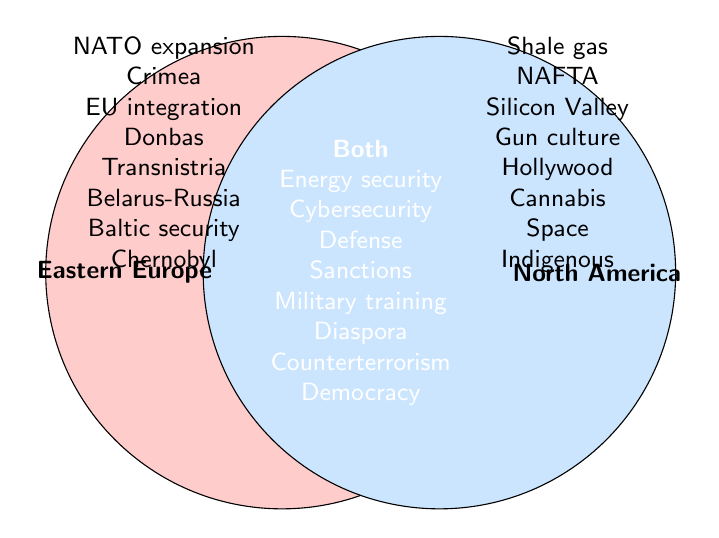What are the geopolitical interests that are exclusive to Eastern Europe? By looking at the left circle labeled "Eastern Europe," we can identify the interests listed in this group that are not shared with North America. These interests are NATO expansion, Crimea annexation, EU integration, Donbas conflict, Transnistria issue, Belarus-Russia relations, Baltic states security, and Chernobyl legacy.
Answer: NATO expansion, Crimea annexation, EU integration, Donbas conflict, Transnistria issue, Belarus-Russia relations, Baltic states security, Chernobyl legacy Which group has the topic of "Cybersecurity"? By examining the overlap section in the Venn Diagram where both circles intersect, "Cybersecurity" is found there, indicating it is a shared interest between Eastern Europe and North America.
Answer: Both How many interests are unique to North America? By counting the topics in the right circle labeled "North America" that do not overlap with the left circle, we find there are eight interests: shale gas revolution, NAFTA, Silicon Valley, gun culture, Hollywood influence, cannabis legalization, space exploration, and indigenous rights.
Answer: 8 Which geopolitical topics are shared between Eastern Europe and North America? By examining the overlapping section of the Venn Diagram, we identify the topics that are common to both regions: energy security, cybersecurity, defense cooperation, economic sanctions, military training, diaspora communities, counterterrorism, and democratic values.
Answer: Energy security, cybersecurity, defense cooperation, economic sanctions, military training, diaspora communities, counterterrorism, democratic values Compare the number of interests specific to Eastern Europe with those specific to North America. Which has more, and by how much? Eastern Europe has 8 unique interests while North America also has 8 unique interests. The count is equal, so neither has more.
Answer: Equal Which side discusses "Energy security" and is it unique or shared? "Energy security" is found in the middle overlapping section of the Venn Diagram, indicating that it is a shared interest between both Eastern Europe and North America.
Answer: Both, shared Identify an interest that deals with natural resources in one of the regions. Looking at the North America circle, the topic of "shale gas revolution" pertains to natural resources. This topic is unique to North America.
Answer: Shale gas revolution 